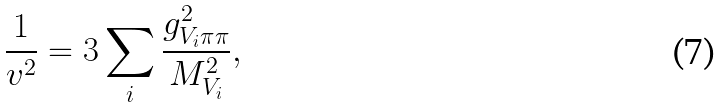Convert formula to latex. <formula><loc_0><loc_0><loc_500><loc_500>\frac { 1 } { v ^ { 2 } } = 3 \sum _ { i } \frac { g _ { V _ { i } \pi \pi } ^ { 2 } } { M _ { V _ { i } } ^ { 2 } } ,</formula> 